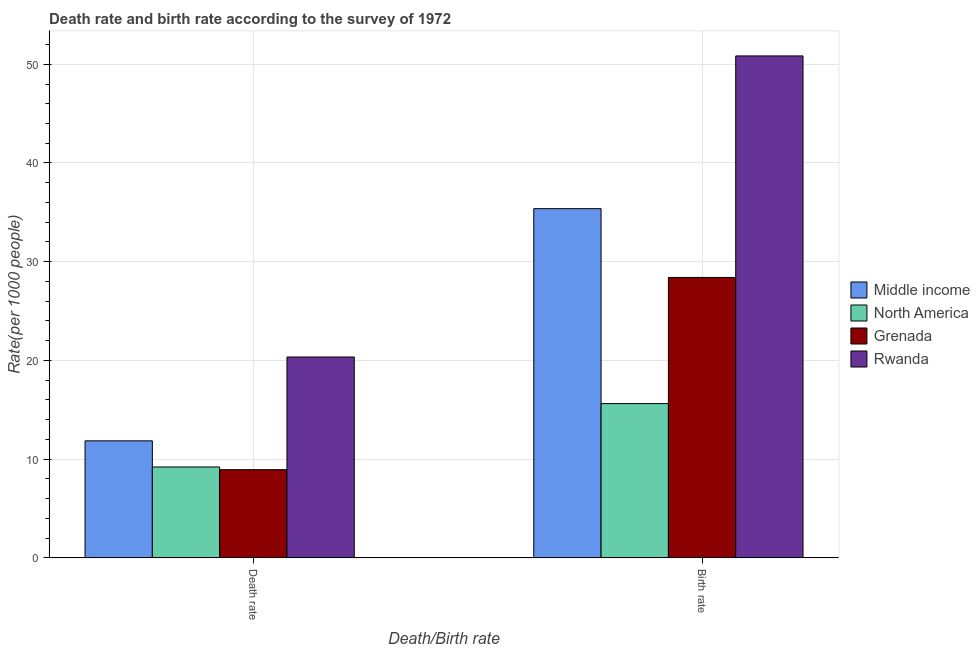How many different coloured bars are there?
Your answer should be compact. 4. How many groups of bars are there?
Keep it short and to the point. 2. Are the number of bars on each tick of the X-axis equal?
Ensure brevity in your answer.  Yes. What is the label of the 1st group of bars from the left?
Make the answer very short. Death rate. What is the death rate in Grenada?
Give a very brief answer. 8.94. Across all countries, what is the maximum death rate?
Offer a terse response. 20.35. Across all countries, what is the minimum death rate?
Make the answer very short. 8.94. In which country was the death rate maximum?
Offer a terse response. Rwanda. What is the total death rate in the graph?
Make the answer very short. 50.35. What is the difference between the birth rate in North America and that in Grenada?
Make the answer very short. -12.78. What is the difference between the death rate in Middle income and the birth rate in North America?
Offer a very short reply. -3.77. What is the average birth rate per country?
Give a very brief answer. 32.56. What is the difference between the death rate and birth rate in Rwanda?
Offer a terse response. -30.5. In how many countries, is the death rate greater than 32 ?
Offer a terse response. 0. What is the ratio of the birth rate in Grenada to that in North America?
Provide a short and direct response. 1.82. Is the birth rate in Rwanda less than that in Middle income?
Provide a succinct answer. No. In how many countries, is the death rate greater than the average death rate taken over all countries?
Offer a terse response. 1. What does the 1st bar from the left in Death rate represents?
Your answer should be very brief. Middle income. What does the 1st bar from the right in Birth rate represents?
Keep it short and to the point. Rwanda. How many bars are there?
Make the answer very short. 8. Are all the bars in the graph horizontal?
Ensure brevity in your answer.  No. Are the values on the major ticks of Y-axis written in scientific E-notation?
Make the answer very short. No. Does the graph contain any zero values?
Provide a succinct answer. No. How many legend labels are there?
Offer a terse response. 4. How are the legend labels stacked?
Provide a short and direct response. Vertical. What is the title of the graph?
Offer a terse response. Death rate and birth rate according to the survey of 1972. What is the label or title of the X-axis?
Provide a short and direct response. Death/Birth rate. What is the label or title of the Y-axis?
Give a very brief answer. Rate(per 1000 people). What is the Rate(per 1000 people) in Middle income in Death rate?
Make the answer very short. 11.86. What is the Rate(per 1000 people) of North America in Death rate?
Your response must be concise. 9.21. What is the Rate(per 1000 people) in Grenada in Death rate?
Keep it short and to the point. 8.94. What is the Rate(per 1000 people) in Rwanda in Death rate?
Make the answer very short. 20.35. What is the Rate(per 1000 people) in Middle income in Birth rate?
Your response must be concise. 35.37. What is the Rate(per 1000 people) in North America in Birth rate?
Your answer should be compact. 15.63. What is the Rate(per 1000 people) of Grenada in Birth rate?
Provide a succinct answer. 28.41. What is the Rate(per 1000 people) in Rwanda in Birth rate?
Provide a succinct answer. 50.84. Across all Death/Birth rate, what is the maximum Rate(per 1000 people) of Middle income?
Your response must be concise. 35.37. Across all Death/Birth rate, what is the maximum Rate(per 1000 people) in North America?
Ensure brevity in your answer.  15.63. Across all Death/Birth rate, what is the maximum Rate(per 1000 people) of Grenada?
Provide a short and direct response. 28.41. Across all Death/Birth rate, what is the maximum Rate(per 1000 people) of Rwanda?
Your response must be concise. 50.84. Across all Death/Birth rate, what is the minimum Rate(per 1000 people) in Middle income?
Your answer should be very brief. 11.86. Across all Death/Birth rate, what is the minimum Rate(per 1000 people) in North America?
Make the answer very short. 9.21. Across all Death/Birth rate, what is the minimum Rate(per 1000 people) of Grenada?
Provide a short and direct response. 8.94. Across all Death/Birth rate, what is the minimum Rate(per 1000 people) in Rwanda?
Provide a short and direct response. 20.35. What is the total Rate(per 1000 people) of Middle income in the graph?
Your answer should be very brief. 47.23. What is the total Rate(per 1000 people) of North America in the graph?
Keep it short and to the point. 24.84. What is the total Rate(per 1000 people) in Grenada in the graph?
Ensure brevity in your answer.  37.34. What is the total Rate(per 1000 people) in Rwanda in the graph?
Your response must be concise. 71.19. What is the difference between the Rate(per 1000 people) in Middle income in Death rate and that in Birth rate?
Your answer should be very brief. -23.52. What is the difference between the Rate(per 1000 people) in North America in Death rate and that in Birth rate?
Your response must be concise. -6.42. What is the difference between the Rate(per 1000 people) in Grenada in Death rate and that in Birth rate?
Offer a terse response. -19.47. What is the difference between the Rate(per 1000 people) of Rwanda in Death rate and that in Birth rate?
Provide a succinct answer. -30.5. What is the difference between the Rate(per 1000 people) in Middle income in Death rate and the Rate(per 1000 people) in North America in Birth rate?
Ensure brevity in your answer.  -3.77. What is the difference between the Rate(per 1000 people) in Middle income in Death rate and the Rate(per 1000 people) in Grenada in Birth rate?
Ensure brevity in your answer.  -16.55. What is the difference between the Rate(per 1000 people) of Middle income in Death rate and the Rate(per 1000 people) of Rwanda in Birth rate?
Provide a succinct answer. -38.99. What is the difference between the Rate(per 1000 people) in North America in Death rate and the Rate(per 1000 people) in Grenada in Birth rate?
Your answer should be very brief. -19.2. What is the difference between the Rate(per 1000 people) of North America in Death rate and the Rate(per 1000 people) of Rwanda in Birth rate?
Ensure brevity in your answer.  -41.64. What is the difference between the Rate(per 1000 people) in Grenada in Death rate and the Rate(per 1000 people) in Rwanda in Birth rate?
Offer a terse response. -41.91. What is the average Rate(per 1000 people) of Middle income per Death/Birth rate?
Give a very brief answer. 23.61. What is the average Rate(per 1000 people) in North America per Death/Birth rate?
Give a very brief answer. 12.42. What is the average Rate(per 1000 people) of Grenada per Death/Birth rate?
Keep it short and to the point. 18.67. What is the average Rate(per 1000 people) of Rwanda per Death/Birth rate?
Keep it short and to the point. 35.6. What is the difference between the Rate(per 1000 people) of Middle income and Rate(per 1000 people) of North America in Death rate?
Provide a succinct answer. 2.65. What is the difference between the Rate(per 1000 people) in Middle income and Rate(per 1000 people) in Grenada in Death rate?
Provide a succinct answer. 2.92. What is the difference between the Rate(per 1000 people) of Middle income and Rate(per 1000 people) of Rwanda in Death rate?
Keep it short and to the point. -8.49. What is the difference between the Rate(per 1000 people) in North America and Rate(per 1000 people) in Grenada in Death rate?
Provide a succinct answer. 0.27. What is the difference between the Rate(per 1000 people) of North America and Rate(per 1000 people) of Rwanda in Death rate?
Offer a very short reply. -11.14. What is the difference between the Rate(per 1000 people) in Grenada and Rate(per 1000 people) in Rwanda in Death rate?
Your answer should be very brief. -11.41. What is the difference between the Rate(per 1000 people) of Middle income and Rate(per 1000 people) of North America in Birth rate?
Give a very brief answer. 19.74. What is the difference between the Rate(per 1000 people) of Middle income and Rate(per 1000 people) of Grenada in Birth rate?
Offer a very short reply. 6.97. What is the difference between the Rate(per 1000 people) in Middle income and Rate(per 1000 people) in Rwanda in Birth rate?
Ensure brevity in your answer.  -15.47. What is the difference between the Rate(per 1000 people) in North America and Rate(per 1000 people) in Grenada in Birth rate?
Your answer should be compact. -12.78. What is the difference between the Rate(per 1000 people) in North America and Rate(per 1000 people) in Rwanda in Birth rate?
Give a very brief answer. -35.22. What is the difference between the Rate(per 1000 people) of Grenada and Rate(per 1000 people) of Rwanda in Birth rate?
Your response must be concise. -22.44. What is the ratio of the Rate(per 1000 people) in Middle income in Death rate to that in Birth rate?
Make the answer very short. 0.34. What is the ratio of the Rate(per 1000 people) of North America in Death rate to that in Birth rate?
Your answer should be very brief. 0.59. What is the ratio of the Rate(per 1000 people) in Grenada in Death rate to that in Birth rate?
Offer a terse response. 0.31. What is the ratio of the Rate(per 1000 people) in Rwanda in Death rate to that in Birth rate?
Your answer should be compact. 0.4. What is the difference between the highest and the second highest Rate(per 1000 people) of Middle income?
Offer a very short reply. 23.52. What is the difference between the highest and the second highest Rate(per 1000 people) of North America?
Provide a short and direct response. 6.42. What is the difference between the highest and the second highest Rate(per 1000 people) of Grenada?
Make the answer very short. 19.47. What is the difference between the highest and the second highest Rate(per 1000 people) in Rwanda?
Your answer should be very brief. 30.5. What is the difference between the highest and the lowest Rate(per 1000 people) of Middle income?
Provide a succinct answer. 23.52. What is the difference between the highest and the lowest Rate(per 1000 people) of North America?
Offer a very short reply. 6.42. What is the difference between the highest and the lowest Rate(per 1000 people) of Grenada?
Offer a very short reply. 19.47. What is the difference between the highest and the lowest Rate(per 1000 people) in Rwanda?
Offer a terse response. 30.5. 